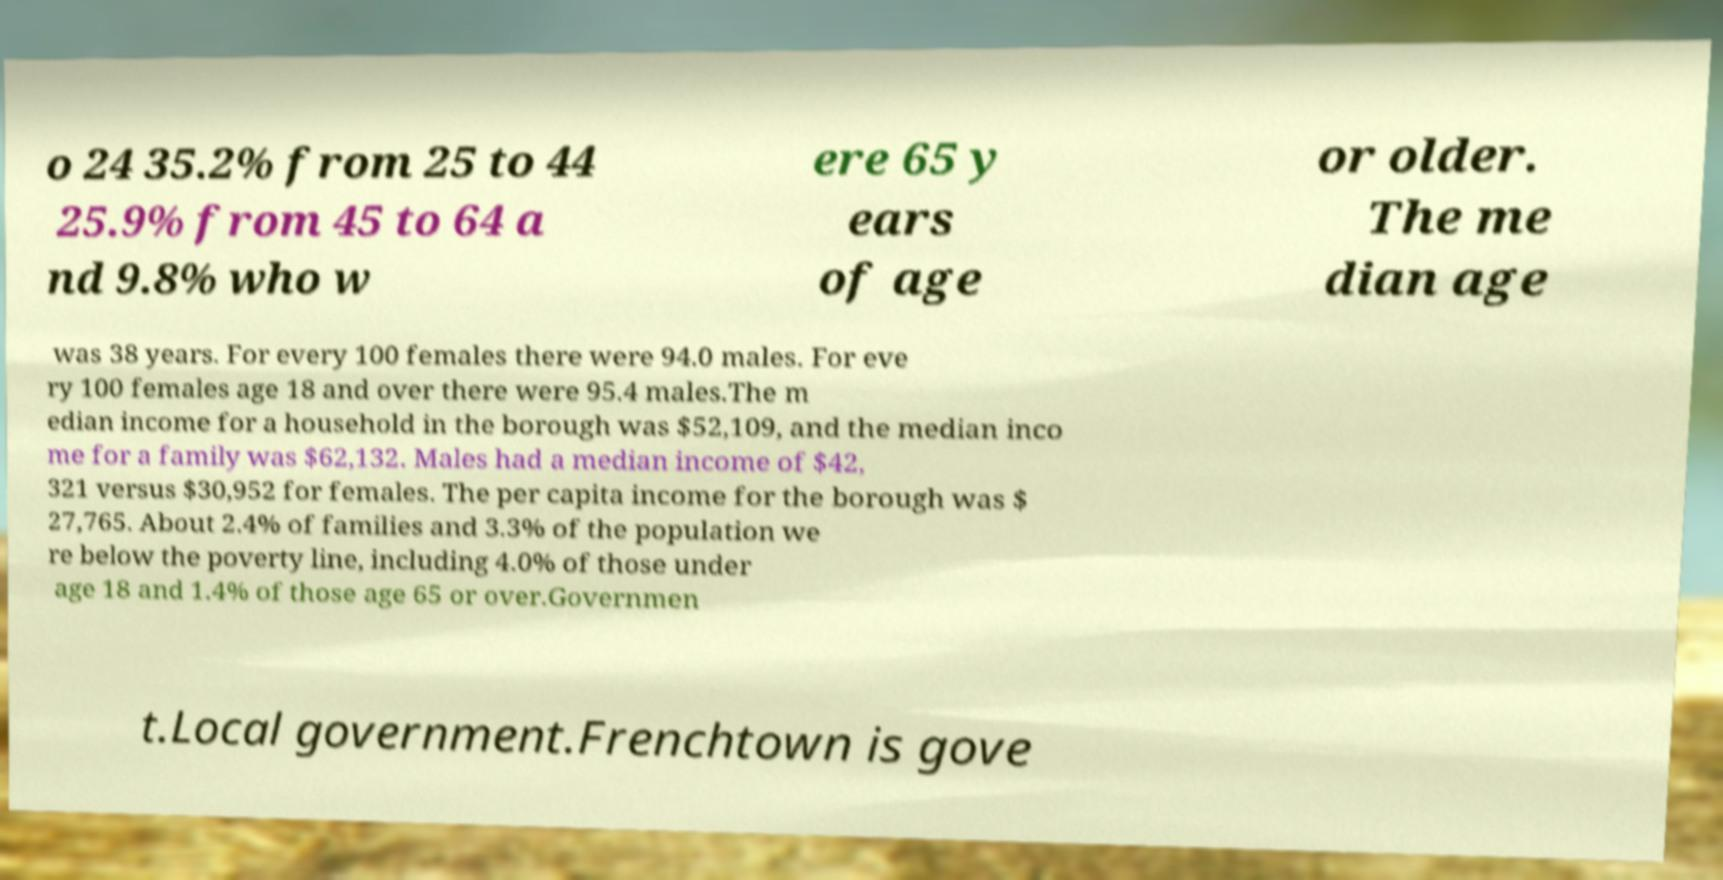Can you accurately transcribe the text from the provided image for me? o 24 35.2% from 25 to 44 25.9% from 45 to 64 a nd 9.8% who w ere 65 y ears of age or older. The me dian age was 38 years. For every 100 females there were 94.0 males. For eve ry 100 females age 18 and over there were 95.4 males.The m edian income for a household in the borough was $52,109, and the median inco me for a family was $62,132. Males had a median income of $42, 321 versus $30,952 for females. The per capita income for the borough was $ 27,765. About 2.4% of families and 3.3% of the population we re below the poverty line, including 4.0% of those under age 18 and 1.4% of those age 65 or over.Governmen t.Local government.Frenchtown is gove 